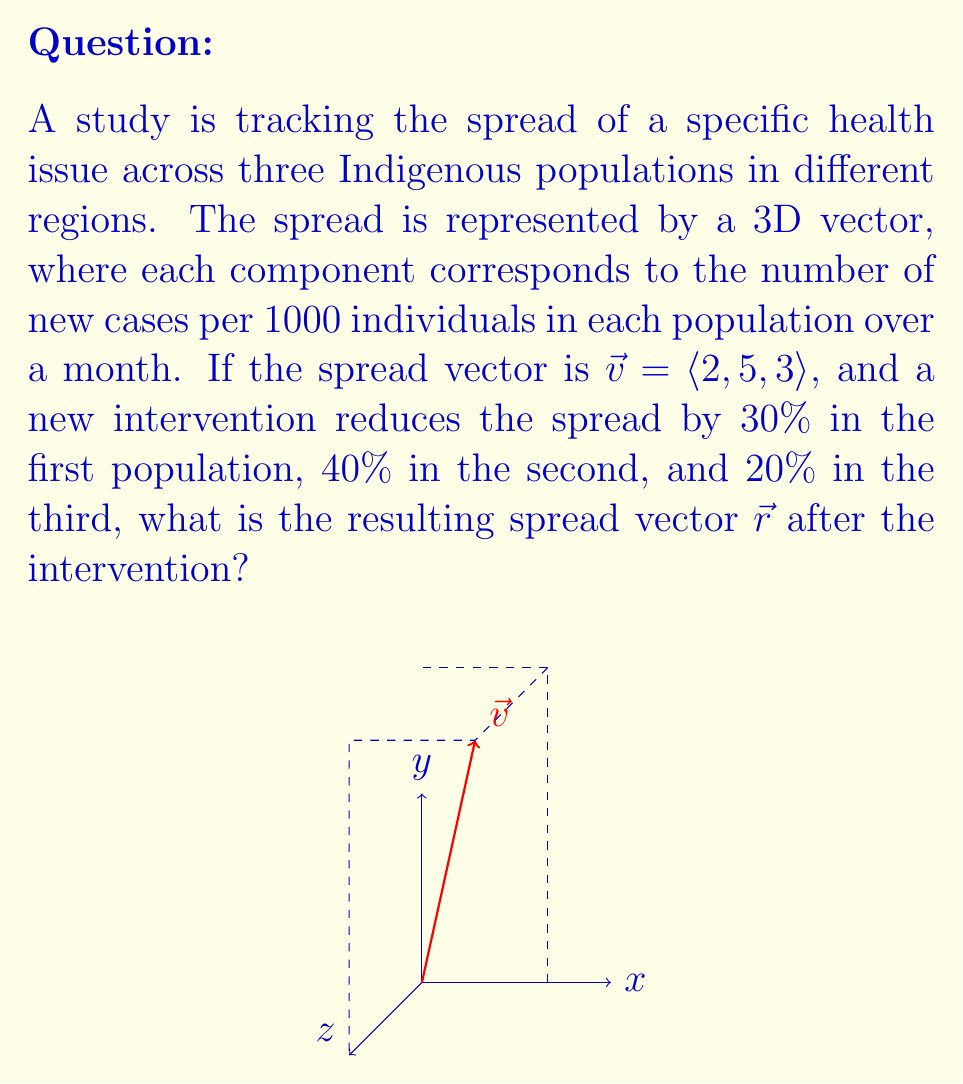Provide a solution to this math problem. To solve this problem, we need to apply the given reductions to each component of the original spread vector. Let's go through this step-by-step:

1) The original spread vector is $\vec{v} = \langle 2, 5, 3 \rangle$.

2) For each component, we need to calculate the reduction and subtract it from the original value:

   First component (30% reduction):
   $$2 - (0.30 \times 2) = 2 - 0.6 = 1.4$$

   Second component (40% reduction):
   $$5 - (0.40 \times 5) = 5 - 2 = 3$$

   Third component (20% reduction):
   $$3 - (0.20 \times 3) = 3 - 0.6 = 2.4$$

3) The resulting spread vector $\vec{r}$ is composed of these new values:

   $$\vec{r} = \langle 1.4, 3, 2.4 \rangle$$

This vector represents the new spread of the health issue across the three Indigenous populations after the intervention, with each component corresponding to the number of new cases per 1000 individuals in each population over a month.
Answer: $\vec{r} = \langle 1.4, 3, 2.4 \rangle$ 